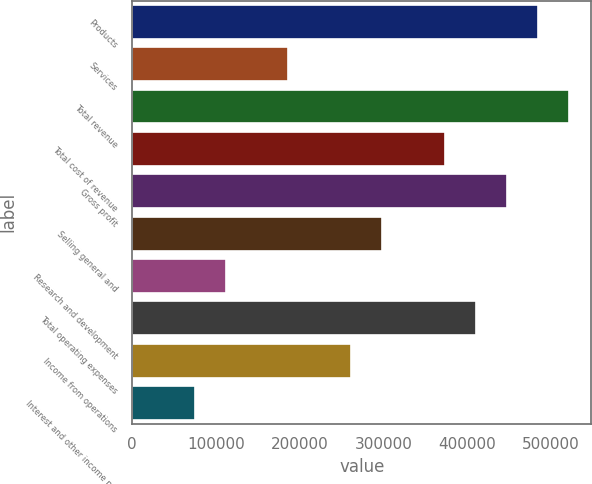Convert chart. <chart><loc_0><loc_0><loc_500><loc_500><bar_chart><fcel>Products<fcel>Services<fcel>Total revenue<fcel>Total cost of revenue<fcel>Gross profit<fcel>Selling general and<fcel>Research and development<fcel>Total operating expenses<fcel>Income from operations<fcel>Interest and other income net<nl><fcel>484486<fcel>186342<fcel>521754<fcel>372682<fcel>447218<fcel>298146<fcel>111806<fcel>409950<fcel>260878<fcel>74537.9<nl></chart> 